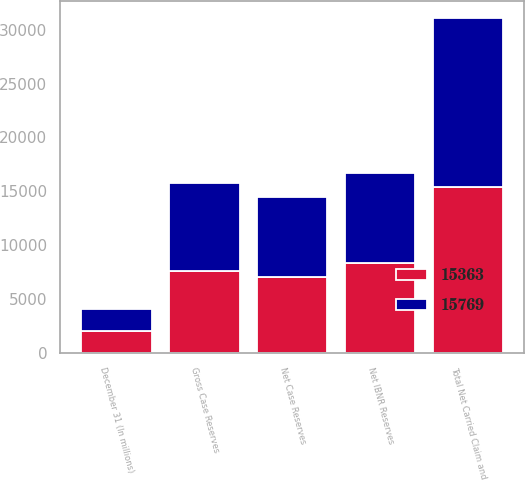<chart> <loc_0><loc_0><loc_500><loc_500><stacked_bar_chart><ecel><fcel>December 31 (In millions)<fcel>Gross Case Reserves<fcel>Net Case Reserves<fcel>Net IBNR Reserves<fcel>Total Net Carried Claim and<nl><fcel>15363<fcel>2015<fcel>7608<fcel>6992<fcel>8371<fcel>15363<nl><fcel>15769<fcel>2014<fcel>8186<fcel>7474<fcel>8295<fcel>15769<nl></chart> 